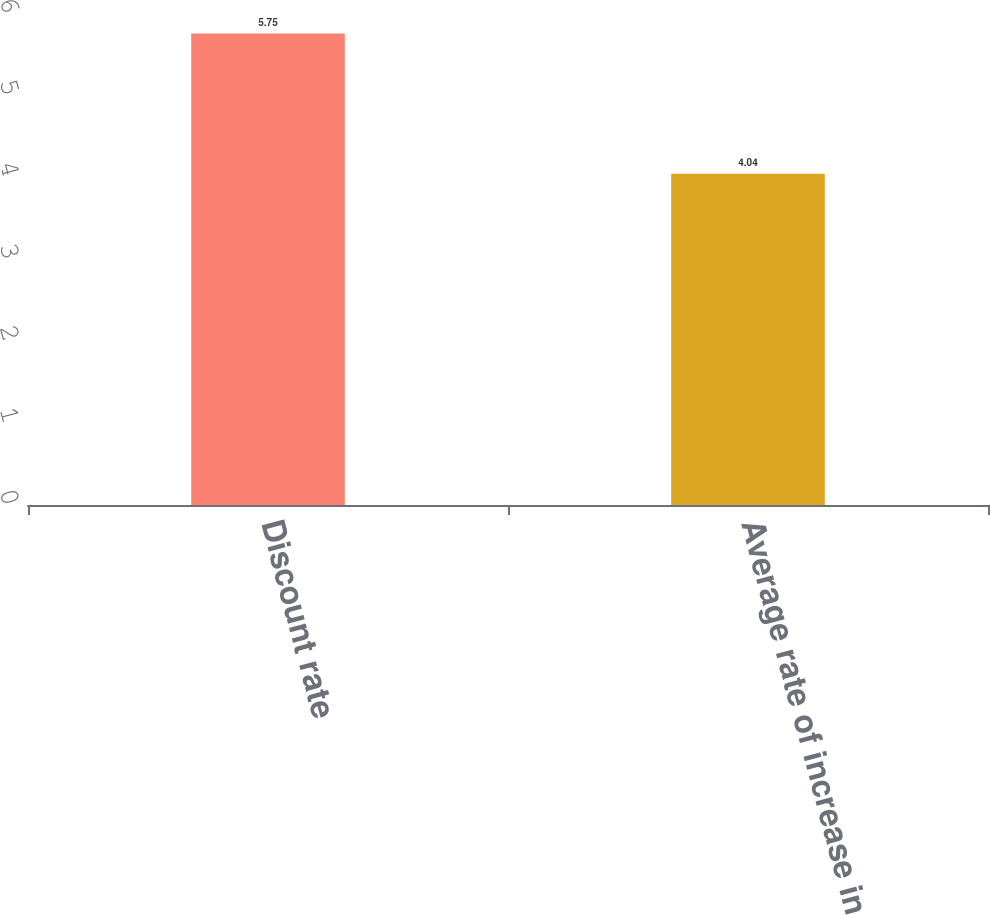Convert chart to OTSL. <chart><loc_0><loc_0><loc_500><loc_500><bar_chart><fcel>Discount rate<fcel>Average rate of increase in<nl><fcel>5.75<fcel>4.04<nl></chart> 